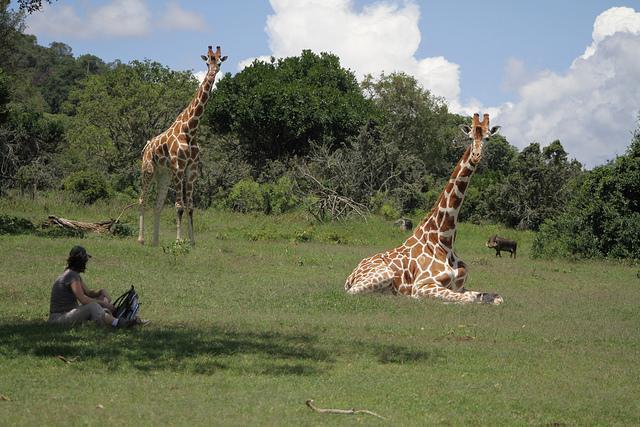Where is the person in?
Choose the right answer from the provided options to respond to the question.
Options: Farm, barn, zoo, wilderness. Wilderness. 